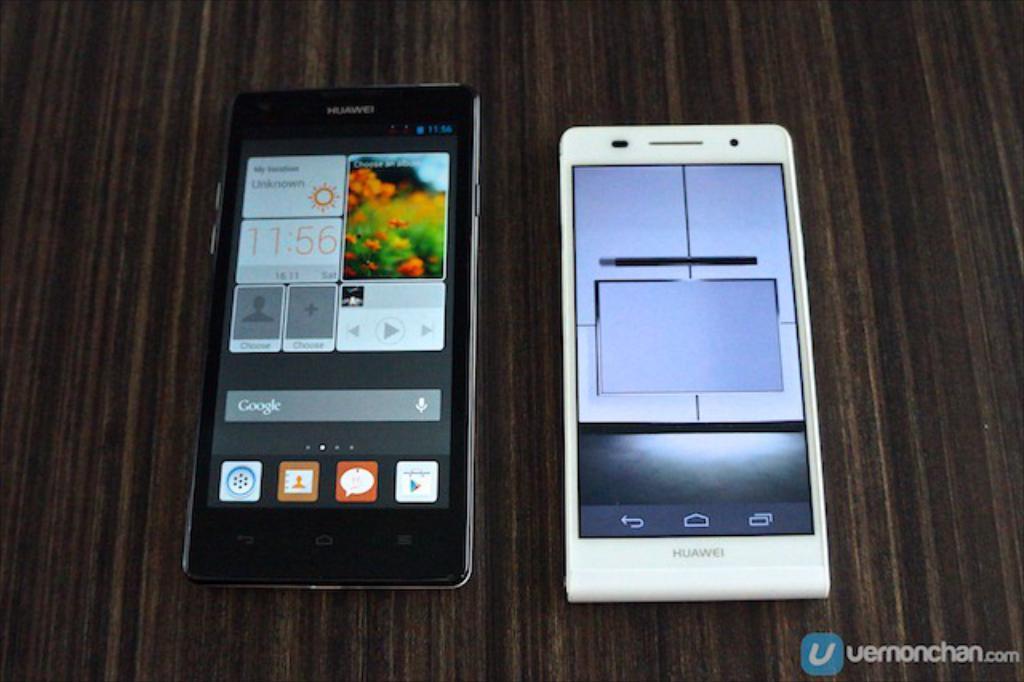Could you give a brief overview of what you see in this image? On the left side there is a mobile phone in black color, on the right side there is another mobile phone in white color. 